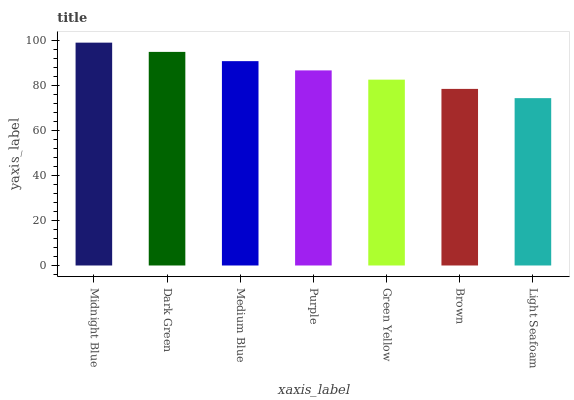Is Light Seafoam the minimum?
Answer yes or no. Yes. Is Midnight Blue the maximum?
Answer yes or no. Yes. Is Dark Green the minimum?
Answer yes or no. No. Is Dark Green the maximum?
Answer yes or no. No. Is Midnight Blue greater than Dark Green?
Answer yes or no. Yes. Is Dark Green less than Midnight Blue?
Answer yes or no. Yes. Is Dark Green greater than Midnight Blue?
Answer yes or no. No. Is Midnight Blue less than Dark Green?
Answer yes or no. No. Is Purple the high median?
Answer yes or no. Yes. Is Purple the low median?
Answer yes or no. Yes. Is Midnight Blue the high median?
Answer yes or no. No. Is Midnight Blue the low median?
Answer yes or no. No. 